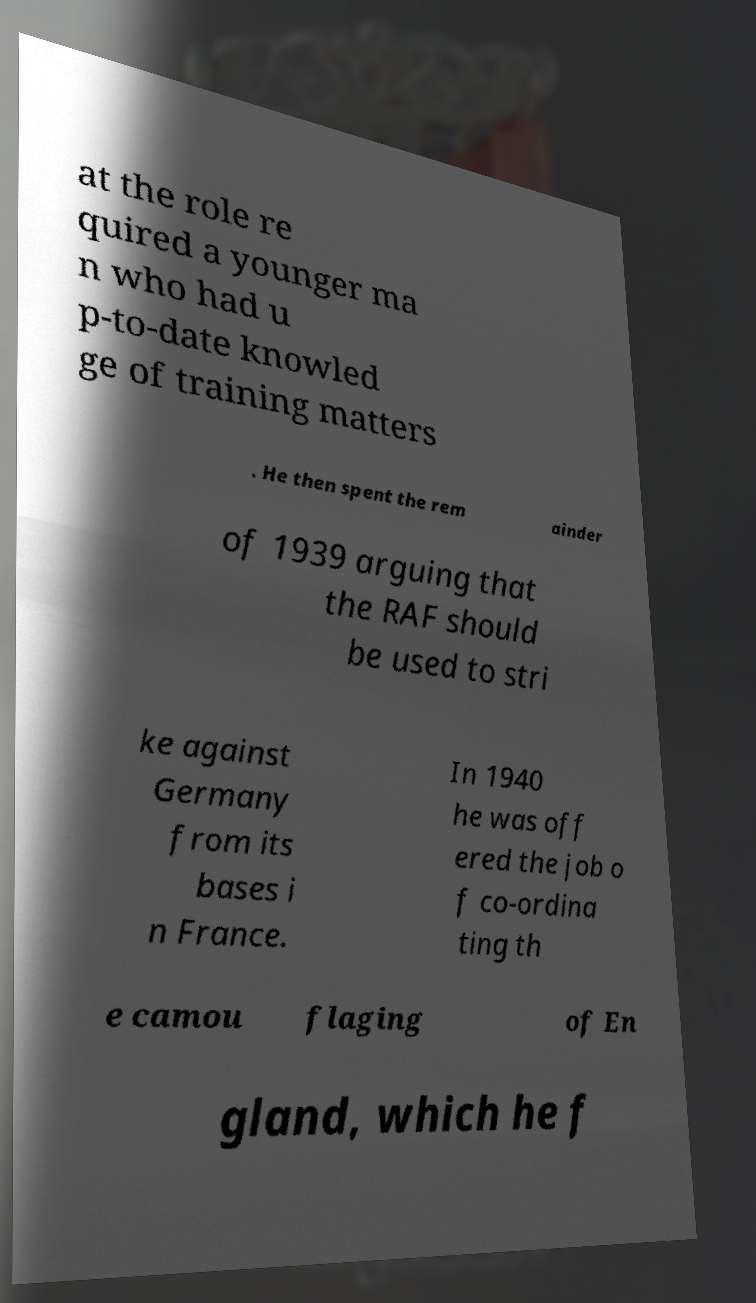Please identify and transcribe the text found in this image. at the role re quired a younger ma n who had u p-to-date knowled ge of training matters . He then spent the rem ainder of 1939 arguing that the RAF should be used to stri ke against Germany from its bases i n France. In 1940 he was off ered the job o f co-ordina ting th e camou flaging of En gland, which he f 